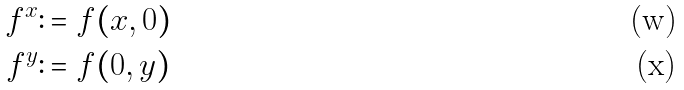<formula> <loc_0><loc_0><loc_500><loc_500>f ^ { x } & \colon = f ( x , 0 ) \\ f ^ { y } & \colon = f ( 0 , y )</formula> 